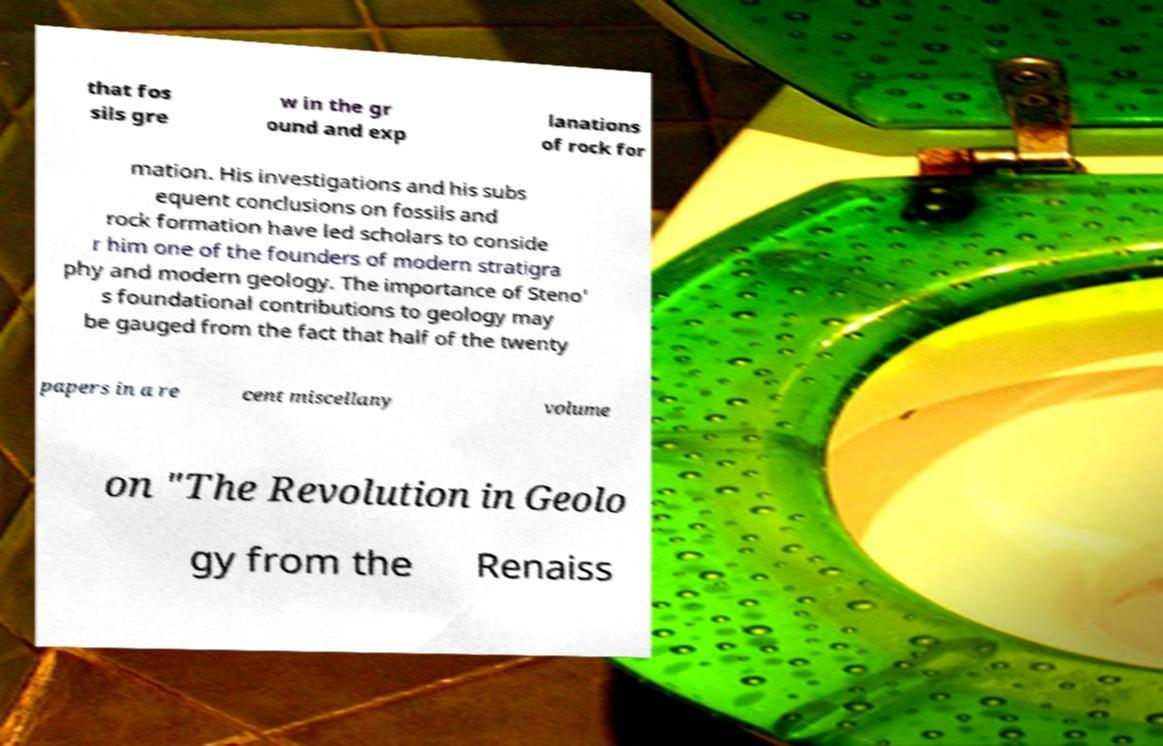What messages or text are displayed in this image? I need them in a readable, typed format. that fos sils gre w in the gr ound and exp lanations of rock for mation. His investigations and his subs equent conclusions on fossils and rock formation have led scholars to conside r him one of the founders of modern stratigra phy and modern geology. The importance of Steno' s foundational contributions to geology may be gauged from the fact that half of the twenty papers in a re cent miscellany volume on "The Revolution in Geolo gy from the Renaiss 